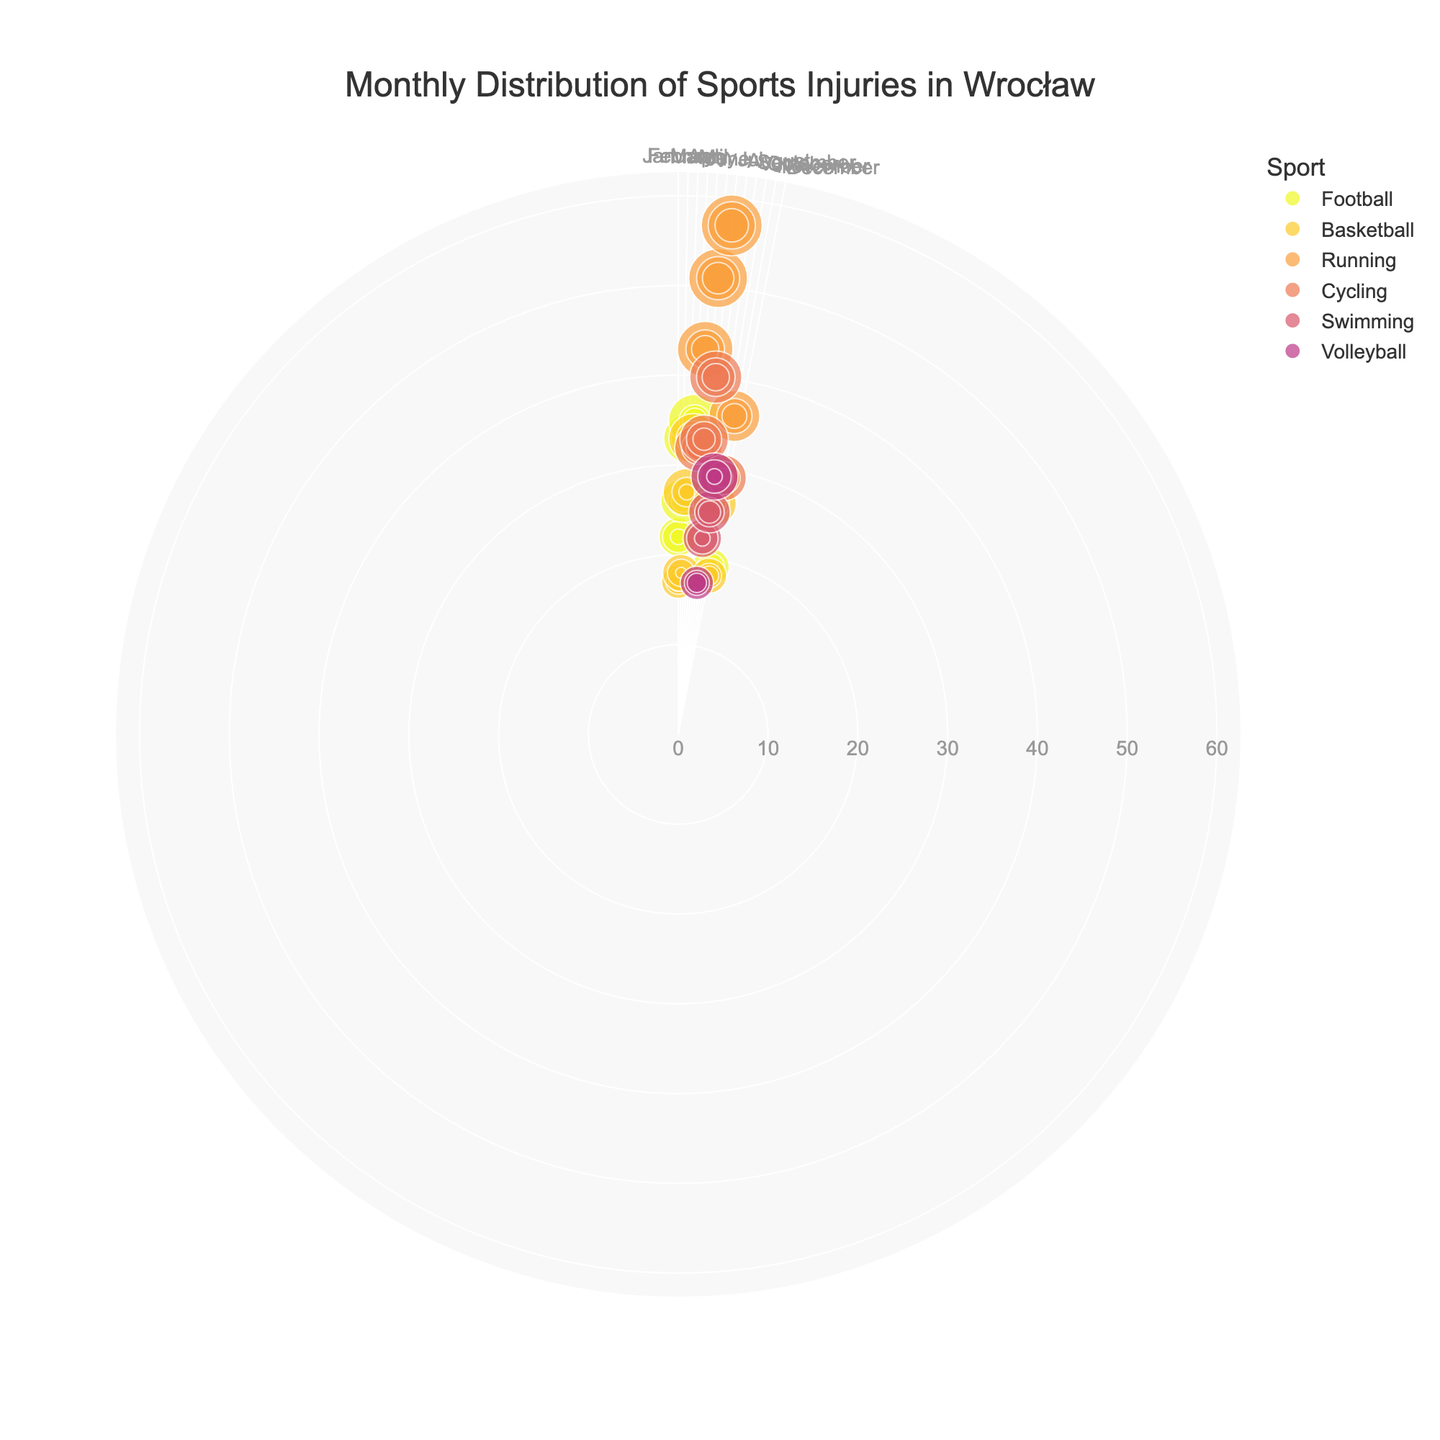What is the overall title of the figure? The title of a plot is usually positioned prominently at the top and gives a brief description of what the figure represents. In this case, based on the code, the title is "Monthly Distribution of Sports Injuries in Wrocław," as it describes what the plot is about.
Answer: Monthly Distribution of Sports Injuries in Wrocław Which month has the highest number of minor injuries for Running? To find the month with the highest number of minor injuries for Running, look at the data points that represent Running with minor severity and compare their radii (which indicate the number of injuries). Observing the polar scatter plot, July has the largest radius for Running minor injuries.
Answer: July Compare the number of severe injuries in Football between January and February. Which month has more severe injuries? To compare the severe injuries for Football between January and February, look at the data points for Football with severe severity and compare their radii (count of injuries) in January and February. From the figure, February has 4 severe injuries while January has only 2.
Answer: February During which month does Basketball have the highest number of moderate injuries? To determine this, observe the data points representing Basketball with moderate severity across all months. The point with the largest radius indicates the highest number of moderate injuries. From the plot, April has the most moderate injuries for Basketball.
Answer: April How does the distribution of minor injuries for Cycling change from May to June? Look at the minor injuries data points for Cycling in May and June. Observe the difference in their radii to see the change. In May, there are 18 minor injuries and in June there are 19, showing a slight increase.
Answer: It increases Which sport has the highest total number of injuries in July? To answer this, identify the data points for all sports in July and see which sport has the largest radius (indicating the highest total number of injuries). The plot shows that Running has the largest radius for July.
Answer: Running How many total injuries are reported for Swimming in August? Find the total radius (i.e., the value of "TotalInjuries") for Swimming in August. According to the plot, Swimming has data points representing 12 minor, 8 moderate, and 2 severe injuries. Summing these up gives 22 total injuries in August.
Answer: 22 What is the trend of Football injuries from October to December? To see the trend, observe the data points for Football over these three months and note how their radii change. In October, the total injuries are 29; in November, there are none, and in December, the total is 19. This indicates a decrease overall.
Answer: Decreasing Which sport has the fewest injuries in May and what is the severity of those injuries? As per the plot, the different sports in May are Running and Cycling. Cycling has a lower total injury count compared to Running. Checking the severity, it shows minor, moderate, and severe injuries. There are 18 minor, 9 moderate, and 5 severe injuries for Cycling.
Answer: Cycling, minor, moderate, and severe Which sport shows the largest month-to-month increase in minor injuries between any two consecutive months? To determine this, compare the increase in the radius of minor injuries data points for each sport across all months. Running shows a noticeable increase from May (25) to June (28), which is the largest month-to-month increase among minor injuries.
Answer: Running 